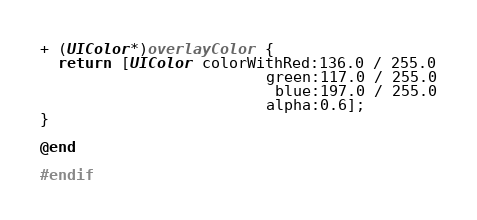<code> <loc_0><loc_0><loc_500><loc_500><_ObjectiveC_>
+ (UIColor*)overlayColor {
  return [UIColor colorWithRed:136.0 / 255.0
                         green:117.0 / 255.0
                          blue:197.0 / 255.0
                         alpha:0.6];
}

@end

#endif
</code> 